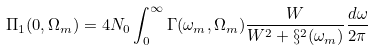<formula> <loc_0><loc_0><loc_500><loc_500>\Pi _ { 1 } ( 0 , \Omega _ { m } ) = 4 N _ { 0 } \int _ { 0 } ^ { \infty } \Gamma ( \omega _ { m } , \Omega _ { m } ) \frac { W } { W ^ { 2 } + \S ^ { 2 } ( \omega _ { m } ) } \frac { d \omega } { 2 \pi }</formula> 